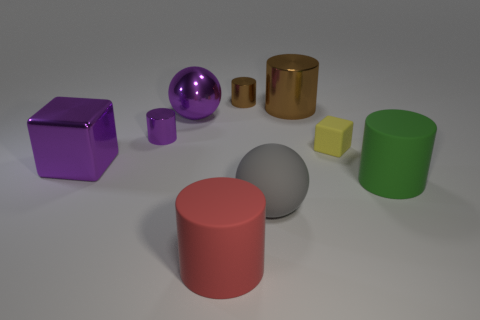What is the material of the tiny thing that is both to the right of the tiny purple thing and to the left of the tiny cube?
Offer a terse response. Metal. What is the shape of the small object that is made of the same material as the small purple cylinder?
Give a very brief answer. Cylinder. Is there anything else that has the same color as the shiny block?
Offer a very short reply. Yes. Are there more big shiny things on the right side of the red rubber cylinder than big gray shiny balls?
Ensure brevity in your answer.  Yes. What material is the purple sphere?
Keep it short and to the point. Metal. How many matte cubes have the same size as the purple shiny block?
Your answer should be very brief. 0. Is the number of blocks right of the green matte object the same as the number of large cylinders that are on the left side of the small yellow matte thing?
Ensure brevity in your answer.  No. Is the small brown cylinder made of the same material as the purple cylinder?
Keep it short and to the point. Yes. Is there a large object behind the small shiny thing that is in front of the large purple sphere?
Keep it short and to the point. Yes. Are there any large brown rubber things that have the same shape as the green object?
Your response must be concise. No. 